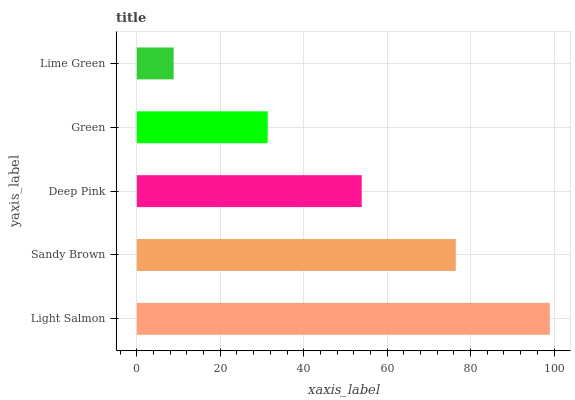Is Lime Green the minimum?
Answer yes or no. Yes. Is Light Salmon the maximum?
Answer yes or no. Yes. Is Sandy Brown the minimum?
Answer yes or no. No. Is Sandy Brown the maximum?
Answer yes or no. No. Is Light Salmon greater than Sandy Brown?
Answer yes or no. Yes. Is Sandy Brown less than Light Salmon?
Answer yes or no. Yes. Is Sandy Brown greater than Light Salmon?
Answer yes or no. No. Is Light Salmon less than Sandy Brown?
Answer yes or no. No. Is Deep Pink the high median?
Answer yes or no. Yes. Is Deep Pink the low median?
Answer yes or no. Yes. Is Green the high median?
Answer yes or no. No. Is Lime Green the low median?
Answer yes or no. No. 